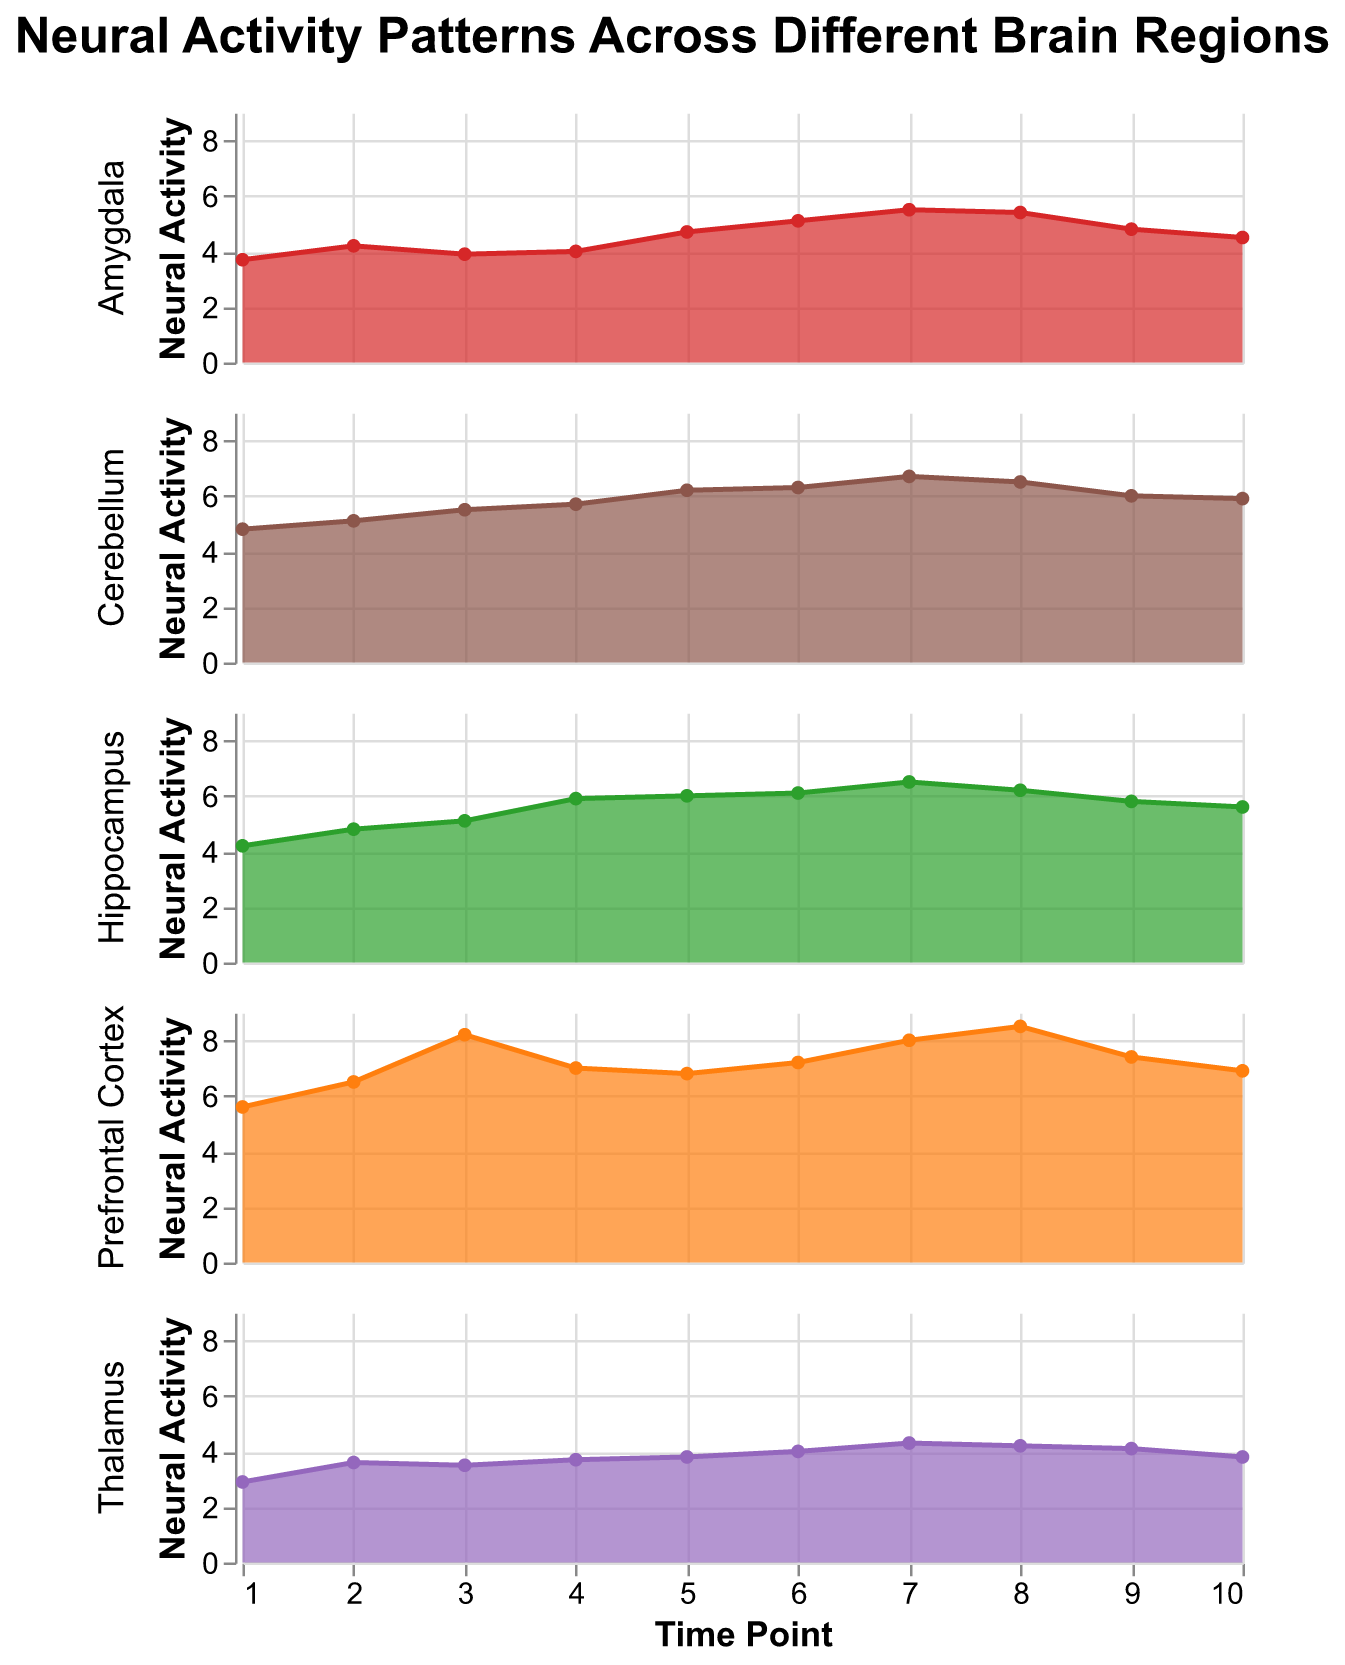What are the regions shown in the title? The title of the figure is "Neural Activity Patterns Across Different Brain Regions," which indicates the regions depicted. Additionally, each subplot corresponds to a specific brain region: Prefrontal Cortex, Hippocampus, Amygdala, Thalamus, and Cerebellum.
Answer: Prefrontal Cortex, Hippocampus, Amygdala, Thalamus, Cerebellum Which brain region shows the highest overall neural activity at any single time point? By examining the plots, the highest single peak in neural activity occurs in the Prefrontal Cortex at TimePoint 3 with a value of 8.2.
Answer: Prefrontal Cortex At which time point does the Hippocampus have the highest neural activity? Observing the Hippocampus subplot, the activity is highest at TimePoint 7, where the value is 6.5.
Answer: TimePoint 7 What is the trend of neural activity in the Amygdala from TimePoint 1 to TimePoint 10? The Amygdala subplot shows an increasing trend from TimePoint 1 to 7, peaking at 5.5, followed by a decreasing trend until TimePoint 10, ending at 4.5.
Answer: Increasing to TimePoint 7, then decreasing Compare the neural activity at TimePoint 5 between the Prefrontal Cortex and the Cerebellum. Which is higher? At TimePoint 5, the Prefrontal Cortex has a neural activity value of 6.8, while the Cerebellum has a value of 6.2. The Prefrontal Cortex is higher.
Answer: Prefrontal Cortex Across which time points does the Thalamus show no increase in neural activity? Observing the Thalamus subplot, the neural activity does not show an increase between TimePoints 2 and 3 (3.6 to 3.5) and between TimePoints 8 and 9 (4.2 to 4.1).
Answer: TimePoint 2 to 3, and 8 to 9 Calculate the average neural activity of the Cerebellum from TimePoint 4 to 6. Adding the values from TimePoint 4 to 6 for the Cerebellum gives 5.7 + 6.2 + 6.3 = 18.2. Dividing by 3 (number of points) results in an average of 18.2 / 3 = 6.07.
Answer: 6.07 Which region shows the most consistent neural activity pattern over time? By comparing the fluctuations in each subplot, the Hippocampus shows the most consistent pattern with gradual changes and fewer extreme variations in neural activity over the 10 time points.
Answer: Hippocampus How does the neural activity in the Prefrontal Cortex at TimePoint 1 compare to the Thalamus at TimePoint 10? At TimePoint 1, the Prefrontal Cortex has a neural activity value of 5.6, while the Thalamus at TimePoint 10 has a value of 3.8. The activity in the Prefrontal Cortex is higher.
Answer: Prefrontal Cortex Identify the time point where the Amygdala surpasses the 5.0 mark for the first time. In the Amygdala subplot, the neural activity surpasses 5.0 for the first time at TimePoint 6 with a value of 5.1.
Answer: TimePoint 6 